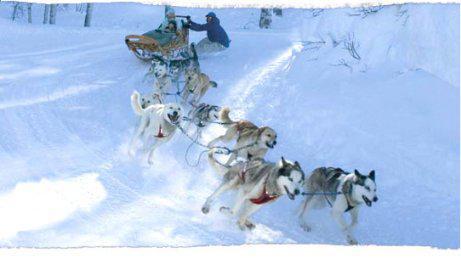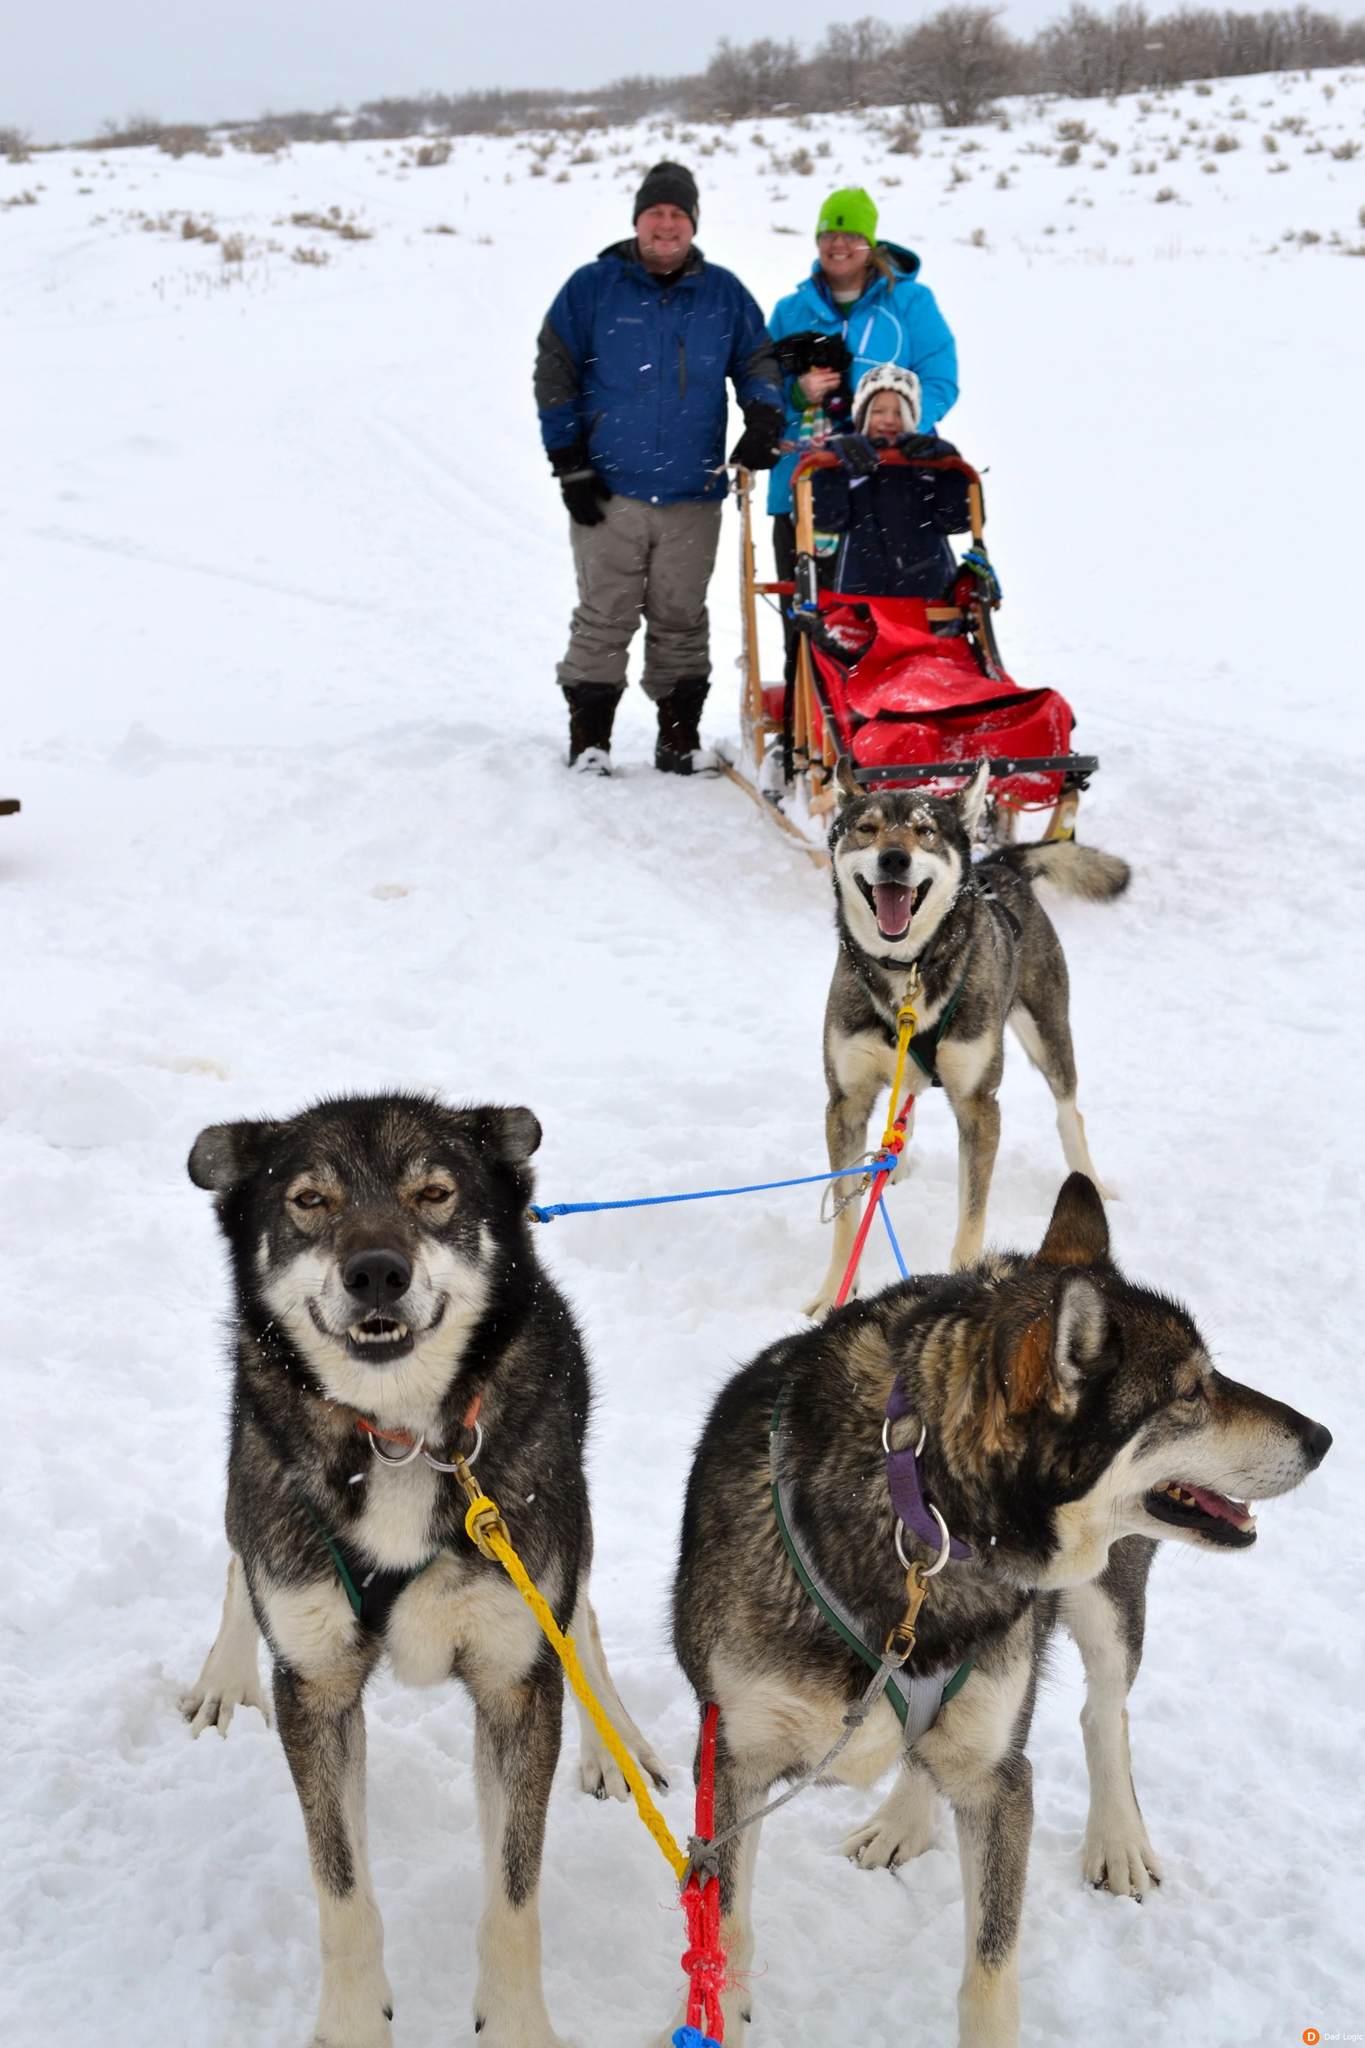The first image is the image on the left, the second image is the image on the right. For the images shown, is this caption "The dog sled team on the right heads diagonally to the left, and the dog team on the left heads toward the camera." true? Answer yes or no. No. The first image is the image on the left, the second image is the image on the right. For the images displayed, is the sentence "The dogs in the left image are standing still, and the dogs in the right image are running." factually correct? Answer yes or no. No. 